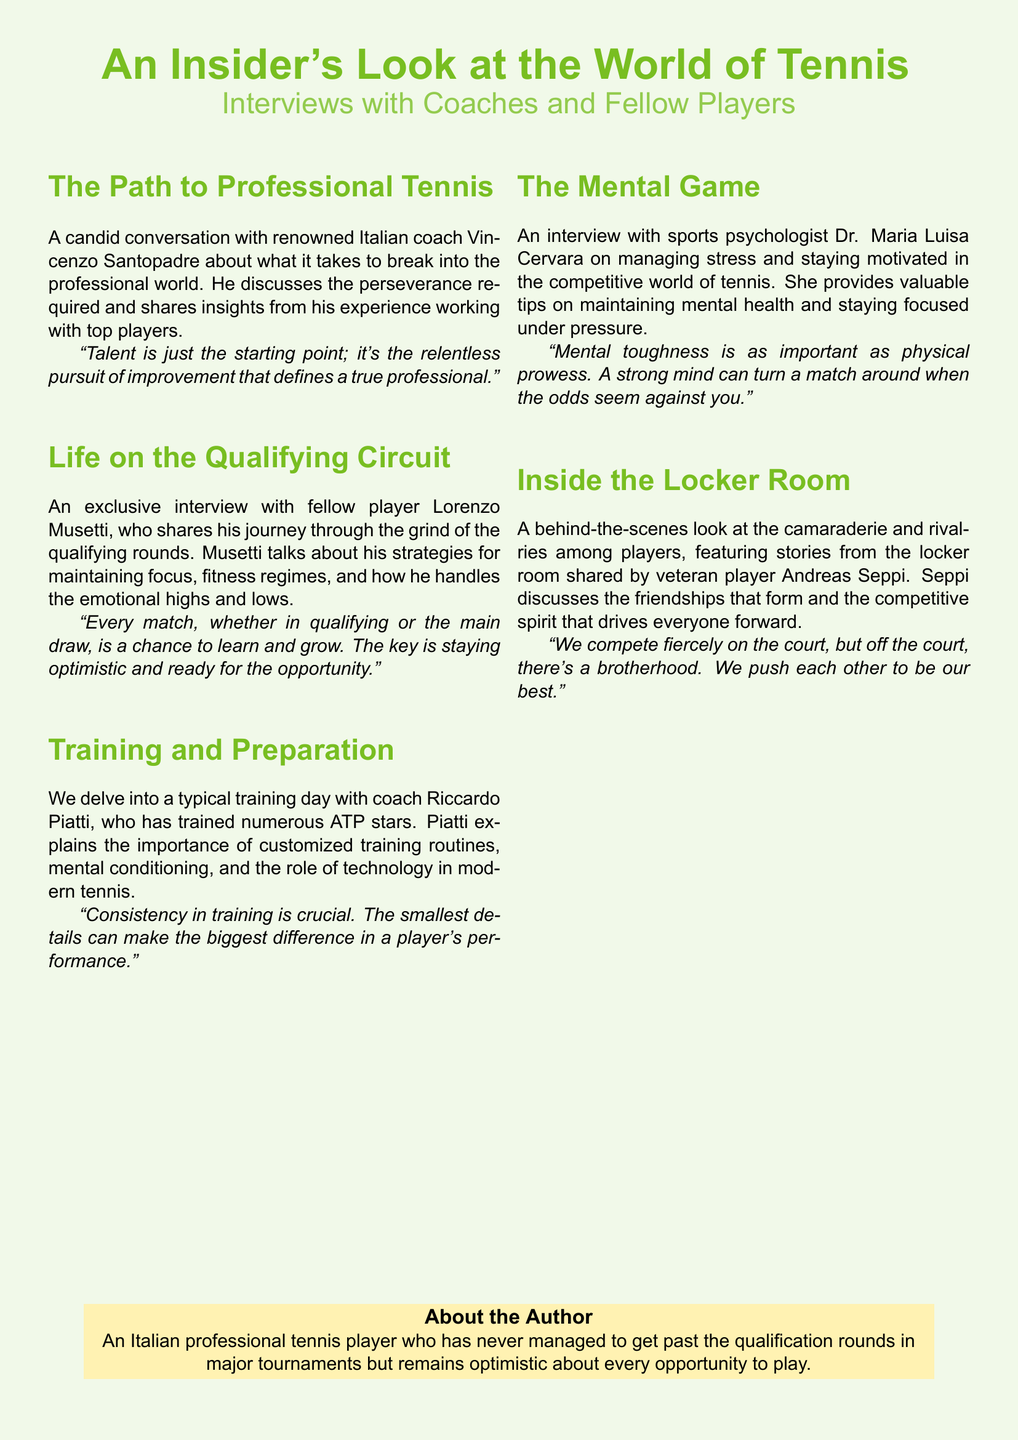What is the name of the Italian coach interviewed? The document mentions a candid conversation with coach Vincenzo Santopadre.
Answer: Vincenzo Santopadre Who shares his journey through the qualifying rounds? Fellow player Lorenzo Musetti talks about his experiences on the qualifying circuit.
Answer: Lorenzo Musetti What is emphasized as crucial in training by coach Riccardo Piatti? Piatti emphasizes that consistency in training is crucial for a player's performance.
Answer: Consistency Who is the sports psychologist mentioned in the document? The interview features Dr. Maria Luisa Cervara, who provides insights on mental health.
Answer: Dr. Maria Luisa Cervara What does Andreas Seppi describe about the locker room? Seppi discusses the friendships and competitive spirit among players in the locker room.
Answer: Camaraderie What is a key takeaway about mental toughness according to Dr. Cervara? Dr. Cervara highlights that a strong mind can turn a match around when under pressure.
Answer: Strong mind Which color is used for the document's background? The background of the document features a light green color.
Answer: Tennis green What sport is the focus of the interviews in the document? The document centers around the sport of tennis.
Answer: Tennis 